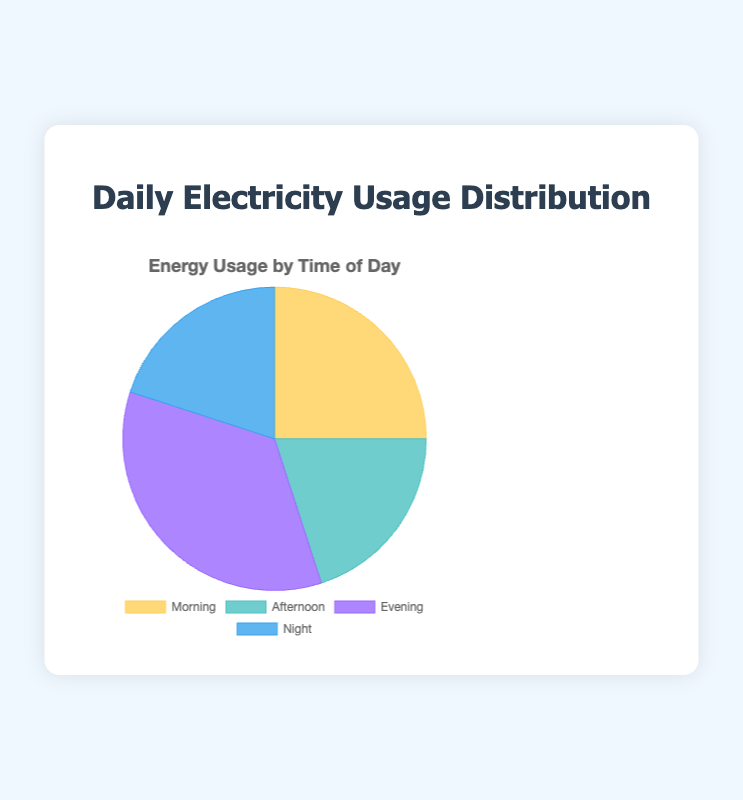What percentage of electricity usage occurs at night? The figure shows that the night represents 20% of the total electricity usage.
Answer: 20% Which time of day has the highest electricity usage? The figure shows that the evening has the highest percentage with 35% of the total electricity usage.
Answer: Evening Compare the electricity usage in the morning and afternoon; which one is higher? The morning has 25% electricity usage, whereas the afternoon has 20%. Therefore, the morning usage is higher.
Answer: Morning What is the combined electricity usage percentage for morning and night? Morning usage is 25% and night usage is 20%. Combined usage is 25% + 20% = 45%.
Answer: 45% What is the difference in electricity usage between the evening and night? Evening usage is 35% and night usage is 20%. The difference is 35% - 20% = 15%.
Answer: 15% What is the average electricity usage of afternoon and evening? The sum of the afternoon (20%) and evening (35%) usage is 20% + 35% = 55%. The average is 55% / 2 = 27.5%.
Answer: 27.5% What is the proportion of total day-time (morning + afternoon) usage compared to evening usage? The day-time usage (morning + afternoon) is 25% + 20% = 45%. Evening usage is 35%. The proportion is 45% compared to 35%.
Answer: 45% to 35% Which color represents the afternoon electricity usage in the figure? According to the figure, afternoon usage is represented by the color blue.
Answer: Blue If you wanted to target the lowest electricity usage time for energy-efficient lighting installation, which time of day would you focus on? The afternoon and night both have the lowest usage at 20%.
Answer: Afternoon or Night What’s the total percentage of energy usage during non-evening times? Non-evening times are morning, afternoon, and night. Their usage percentages are 25%, 20%, and 20%, respectively. The total is 25% + 20% + 20% = 65%.
Answer: 65% 